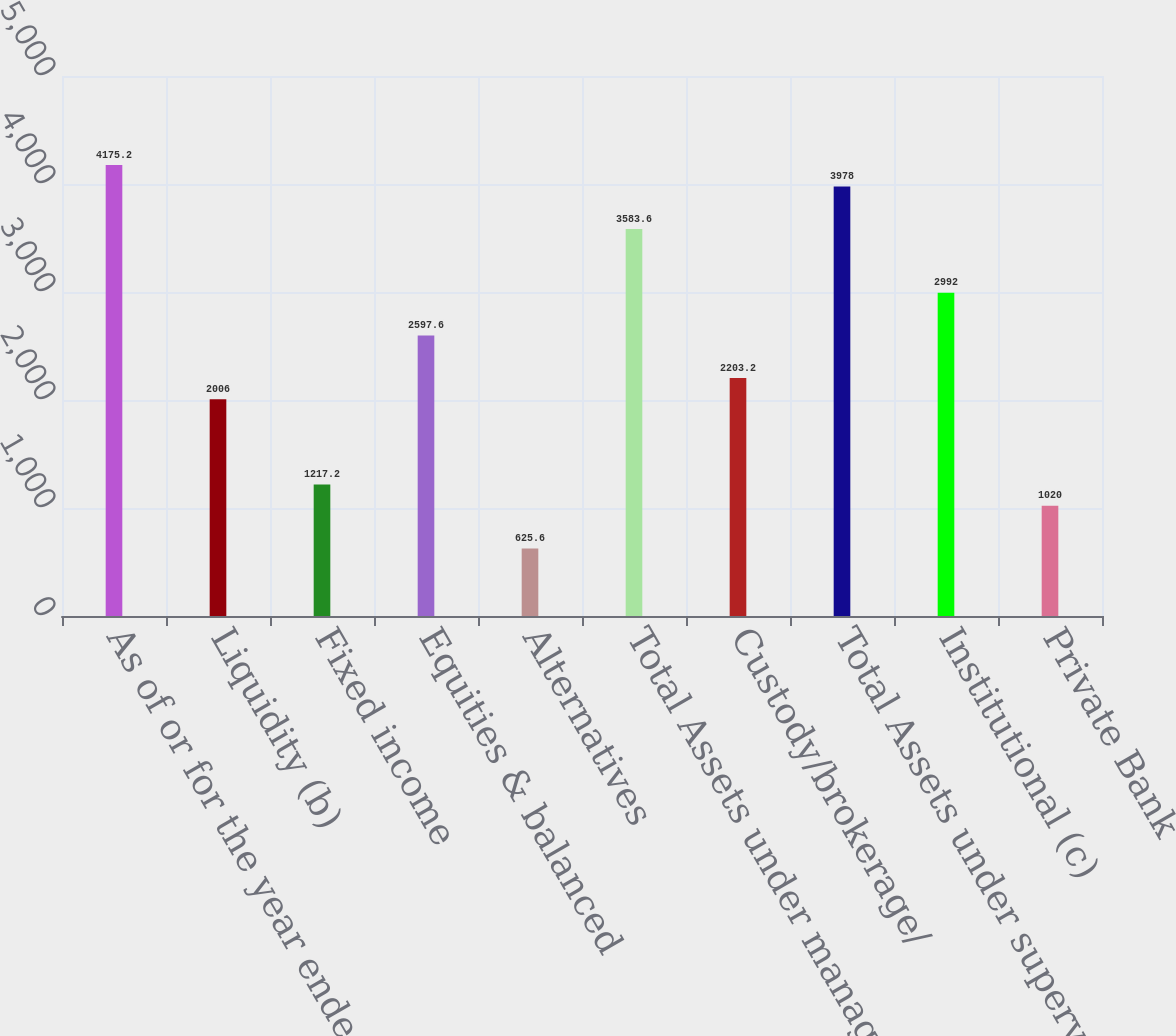Convert chart to OTSL. <chart><loc_0><loc_0><loc_500><loc_500><bar_chart><fcel>As of or for the year ended<fcel>Liquidity (b)<fcel>Fixed income<fcel>Equities & balanced<fcel>Alternatives<fcel>Total Assets under management<fcel>Custody/brokerage/<fcel>Total Assets under supervision<fcel>Institutional (c)<fcel>Private Bank<nl><fcel>4175.2<fcel>2006<fcel>1217.2<fcel>2597.6<fcel>625.6<fcel>3583.6<fcel>2203.2<fcel>3978<fcel>2992<fcel>1020<nl></chart> 